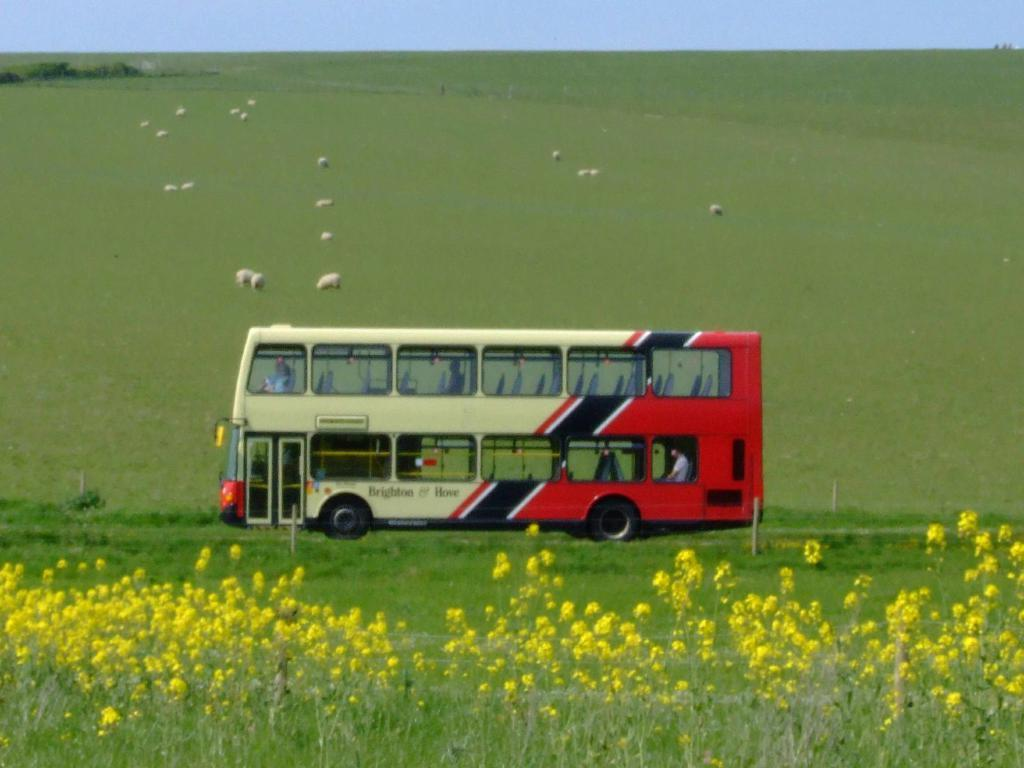What type of vehicle is in the image? There is a bus in the image. Who or what can be seen inside the bus? There are people inside the bus. What other living organisms are visible in the image? Animals are visible in the image. What type of flora is present in the image? Flowers, plants, and grass are present in the image. What structures are visible in the image? Poles are visible in the image. What type of vegetation is present in the background of the image? Trees are present in the image. What part of the natural environment is visible in the background of the image? The sky is visible in the background of the image. What type of comfort does the grandmother provide to the people on the bus in the image? There is no grandmother present in the image, and therefore no comfort can be provided by her. What phase is the moon in during the scene depicted in the image? The moon is not visible in the image, so its phase cannot be determined. 